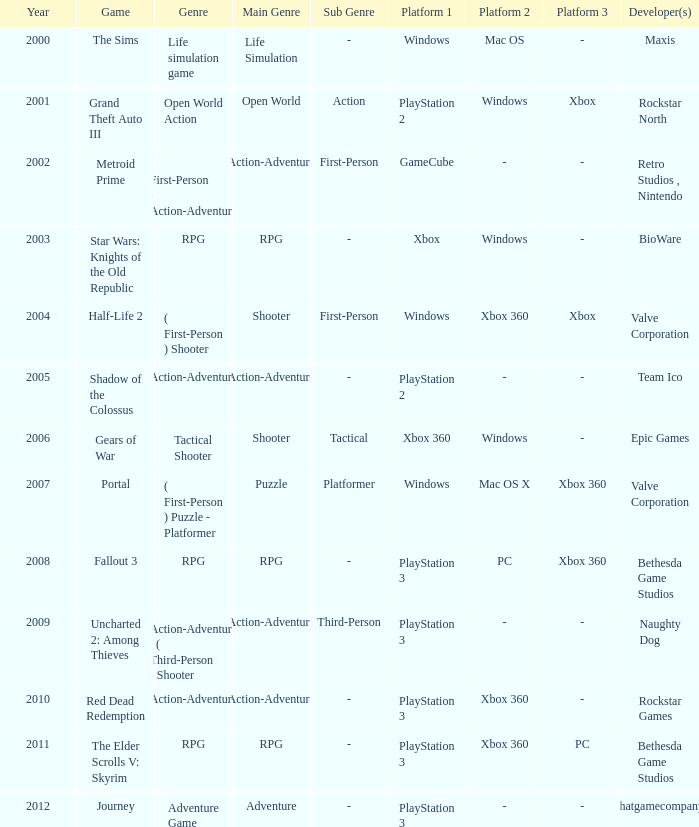What's the genre of The Sims before 2002? Life simulation game. Parse the table in full. {'header': ['Year', 'Game', 'Genre', 'Main Genre', 'Sub Genre', 'Platform 1', 'Platform 2', 'Platform 3', 'Developer(s)'], 'rows': [['2000', 'The Sims', 'Life simulation game', 'Life Simulation', '-', 'Windows', 'Mac OS', '-', 'Maxis'], ['2001', 'Grand Theft Auto III', 'Open World Action', 'Open World', 'Action', 'PlayStation 2', 'Windows', 'Xbox', 'Rockstar North'], ['2002', 'Metroid Prime', '( First-Person ) Action-Adventure', 'Action-Adventure', 'First-Person', 'GameCube', '-', '-', 'Retro Studios , Nintendo'], ['2003', 'Star Wars: Knights of the Old Republic', 'RPG', 'RPG', '-', 'Xbox', 'Windows', '-', 'BioWare'], ['2004', 'Half-Life 2', '( First-Person ) Shooter', 'Shooter', 'First-Person', 'Windows', 'Xbox 360', 'Xbox', 'Valve Corporation'], ['2005', 'Shadow of the Colossus', 'Action-Adventure', 'Action-Adventure', '-', 'PlayStation 2', '-', '-', 'Team Ico'], ['2006', 'Gears of War', 'Tactical Shooter', 'Shooter', 'Tactical', 'Xbox 360', 'Windows', '-', 'Epic Games'], ['2007', 'Portal', '( First-Person ) Puzzle - Platformer', 'Puzzle', 'Platformer', 'Windows', 'Mac OS X', 'Xbox 360', 'Valve Corporation'], ['2008', 'Fallout 3', 'RPG', 'RPG', '-', 'PlayStation 3', 'PC', 'Xbox 360', 'Bethesda Game Studios'], ['2009', 'Uncharted 2: Among Thieves', 'Action-Adventure : ( Third-Person ) Shooter', 'Action-Adventure', 'Third-Person', 'PlayStation 3', '-', '-', 'Naughty Dog'], ['2010', 'Red Dead Redemption', 'Action-Adventure', 'Action-Adventure', '-', 'PlayStation 3', 'Xbox 360', '-', 'Rockstar Games'], ['2011', 'The Elder Scrolls V: Skyrim', 'RPG', 'RPG', '-', 'PlayStation 3', 'Xbox 360', 'PC', 'Bethesda Game Studios'], ['2012', 'Journey', 'Adventure Game', 'Adventure', '-', 'PlayStation 3', '-', '-', 'thatgamecompany']]} 